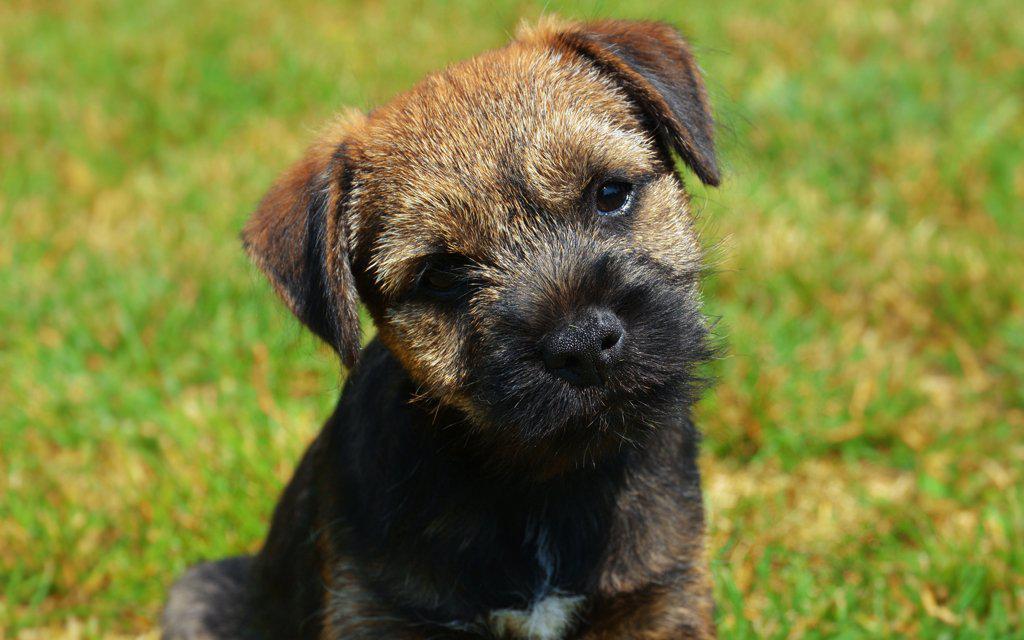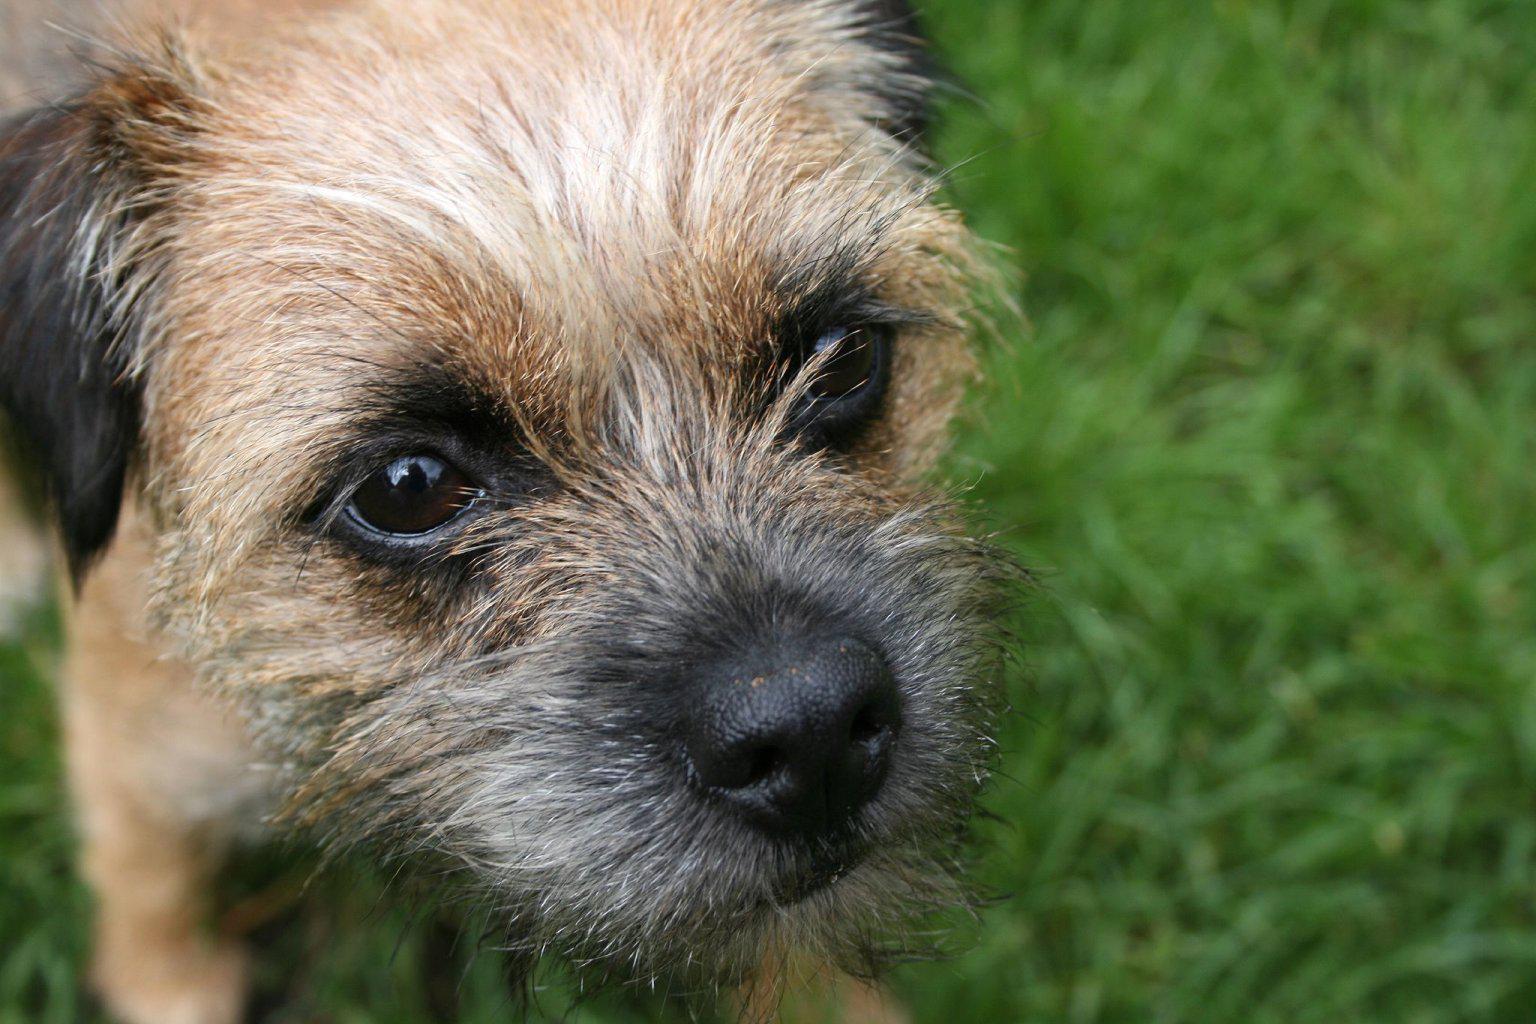The first image is the image on the left, the second image is the image on the right. Evaluate the accuracy of this statement regarding the images: "Left image shows one dog wearing something colorful around its neck.". Is it true? Answer yes or no. No. The first image is the image on the left, the second image is the image on the right. For the images shown, is this caption "One puppy is wearing a colorful color." true? Answer yes or no. No. 